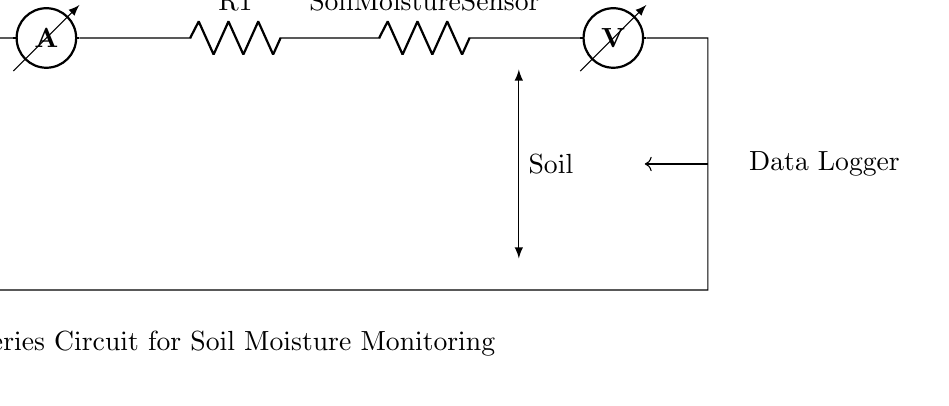What is the power source in this circuit? The power source is represented by the symbol for the battery, labeled as Vcc. It supplies the necessary electrical energy to the circuit.
Answer: Vcc What component measures current in the circuit? The ammeter is the component designed to measure current flow in the circuit. It is shown in series, ensuring all current passes through it.
Answer: Ammeter What is the purpose of the resistor labeled as Soil Moisture Sensor? The Soil Moisture Sensor acts as a resistor that varies in resistance depending on the moisture level in the soil. The changing resistance affects the overall current and voltage in the circuit.
Answer: Varies with moisture How does this circuit demonstrate a series configuration? In a series configuration, all components are connected end-to-end, meaning the same current flows through each component sequentially. Here, the battery, ammeter, and resistors are connected in a single path.
Answer: Single path connection What does the voltmeter measure in this circuit? The voltmeter measures the voltage (potential difference) across the Soil Moisture Sensor. It is essential for determining how moisture levels influence resistance and the corresponding changes in voltage.
Answer: Voltage across sensor If the resistance of the Soil Moisture Sensor decreases, what happens to the current? According to Ohm's Law, if resistance decreases in a series circuit with a constant voltage, the current will increase. This is due to less opposition to the flow of current.
Answer: Current increases What is the role of the Data Logger in this circuit? The Data Logger records voltage readings from the voltmeter over time, allowing for analysis of soil moisture levels and trends during environmental studies.
Answer: Records voltage readings 